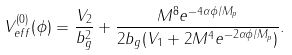Convert formula to latex. <formula><loc_0><loc_0><loc_500><loc_500>V _ { e f f } ^ { ( 0 ) } ( \phi ) = \frac { V _ { 2 } } { b _ { g } ^ { 2 } } + \frac { M ^ { 8 } e ^ { - 4 \alpha \phi / M _ { p } } } { 2 b _ { g } ( V _ { 1 } + 2 M ^ { 4 } e ^ { - 2 \alpha \phi / M _ { p } } ) } .</formula> 